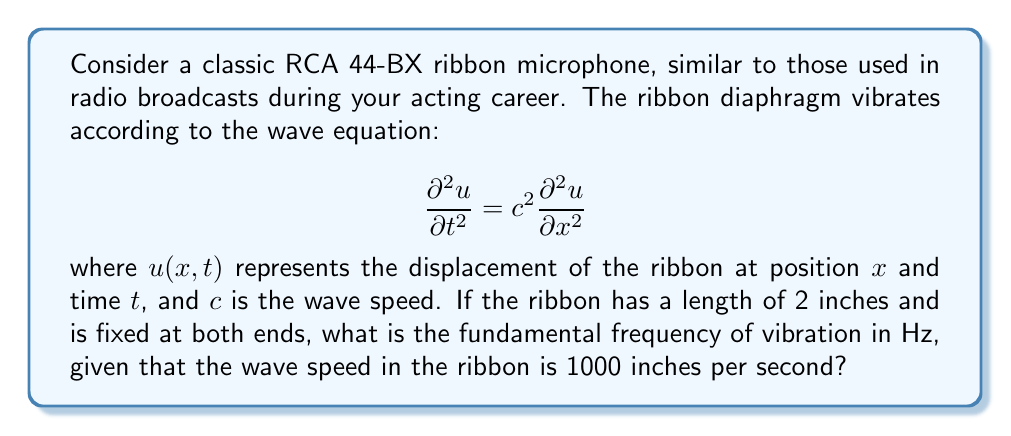Provide a solution to this math problem. To solve this problem, we'll follow these steps:

1) For a string (or ribbon) fixed at both ends, the general solution to the wave equation is:

   $$u(x,t) = \sum_{n=1}^{\infty} A_n \sin(\frac{n\pi x}{L}) \cos(\frac{n\pi c t}{L})$$

   where $L$ is the length of the string.

2) The fundamental frequency corresponds to $n=1$. The frequency $f$ is related to the angular frequency $\omega$ by:

   $$f = \frac{\omega}{2\pi}$$

3) From the cosine term in the general solution, we can see that:

   $$\omega = \frac{\pi c}{L}$$

4) Substituting this into the frequency equation:

   $$f = \frac{c}{2L}$$

5) Now, let's plug in our values:
   - $c = 1000$ inches/second
   - $L = 2$ inches

   $$f = \frac{1000}{2(2)} = \frac{1000}{4} = 250$$

Therefore, the fundamental frequency is 250 Hz.
Answer: 250 Hz 